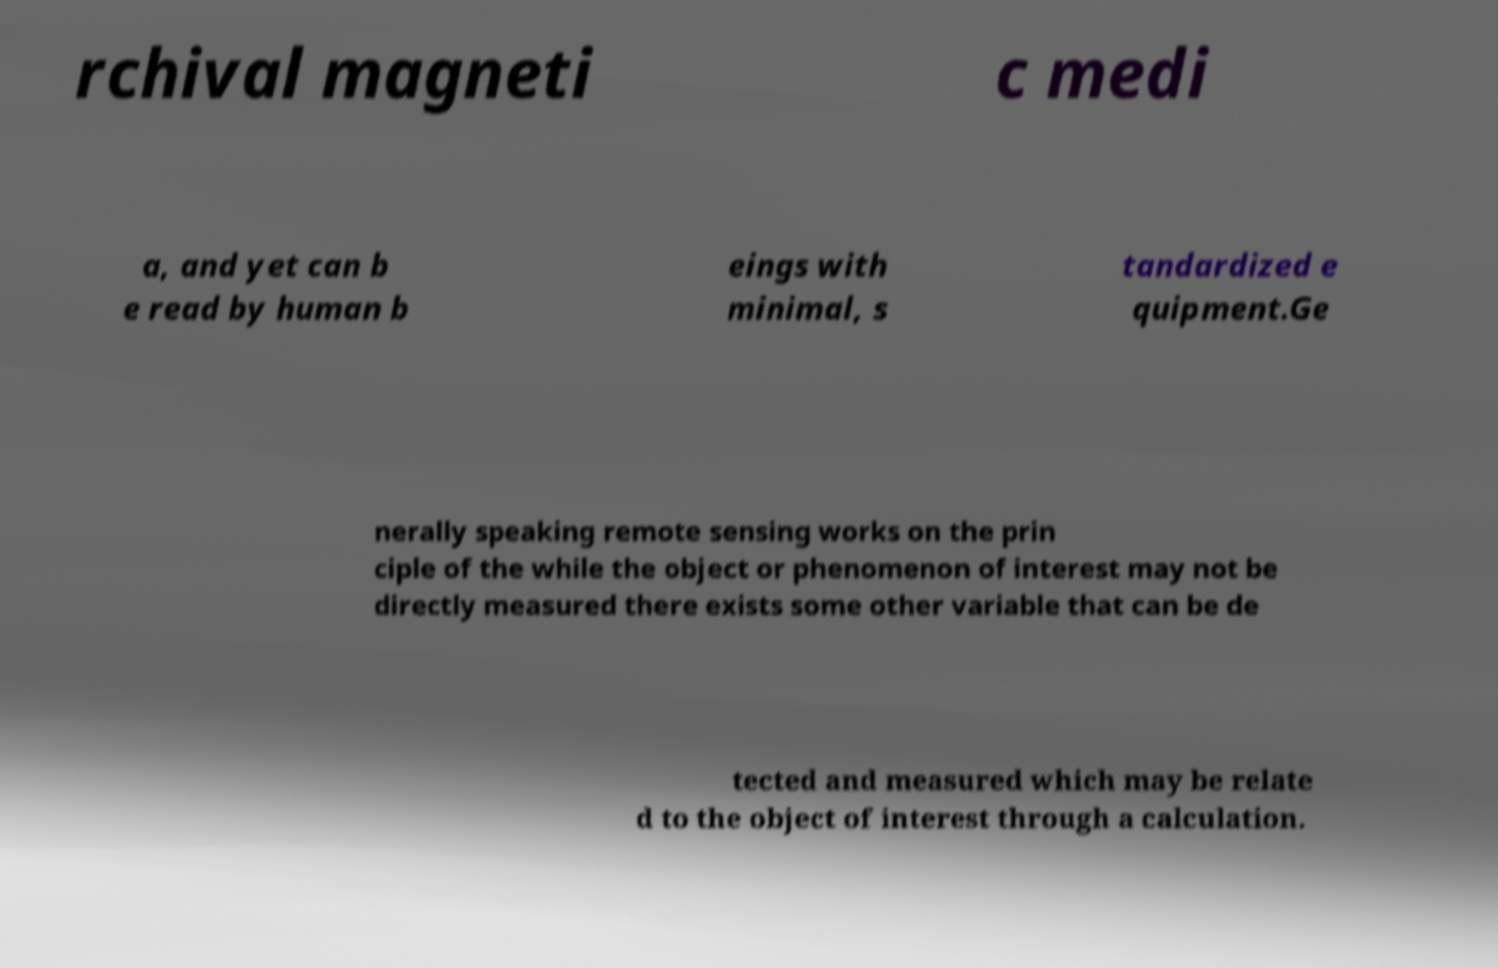I need the written content from this picture converted into text. Can you do that? rchival magneti c medi a, and yet can b e read by human b eings with minimal, s tandardized e quipment.Ge nerally speaking remote sensing works on the prin ciple of the while the object or phenomenon of interest may not be directly measured there exists some other variable that can be de tected and measured which may be relate d to the object of interest through a calculation. 